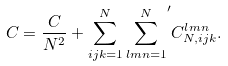Convert formula to latex. <formula><loc_0><loc_0><loc_500><loc_500>C = \frac { C } { N ^ { 2 } } + \sum _ { i j k = 1 } ^ { N } { \sum _ { l m n = 1 } ^ { N } } ^ { \prime } C ^ { l m n } _ { N , i j k } .</formula> 